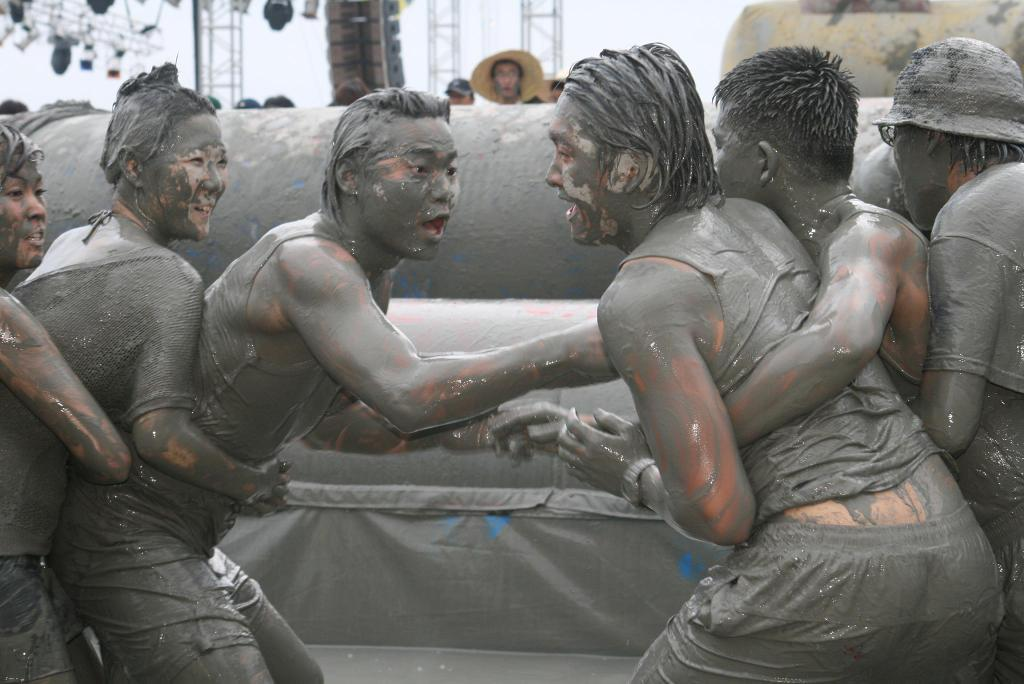What can be seen in the image? There is a group of people in the image. What is the color of the objects in the background? The objects in the background are in gray color. What else can be seen in the background? There are poles and lights in the background. What is the color of the sky in the image? The sky is in white color. What type of toy can be seen in the hands of the people in the image? There is no toy present in the image; the people are not holding any objects. 